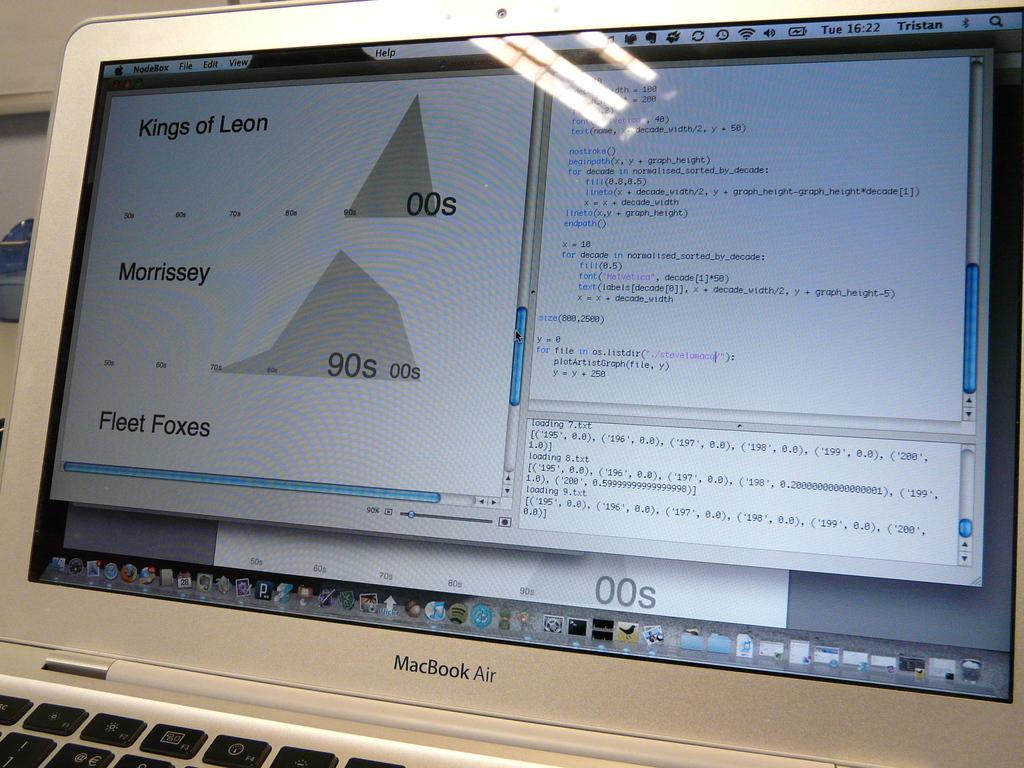What kind of laptop is this?
Your response must be concise. Macbook air. How many "s" are the kings of leon?
Your response must be concise. 1. 